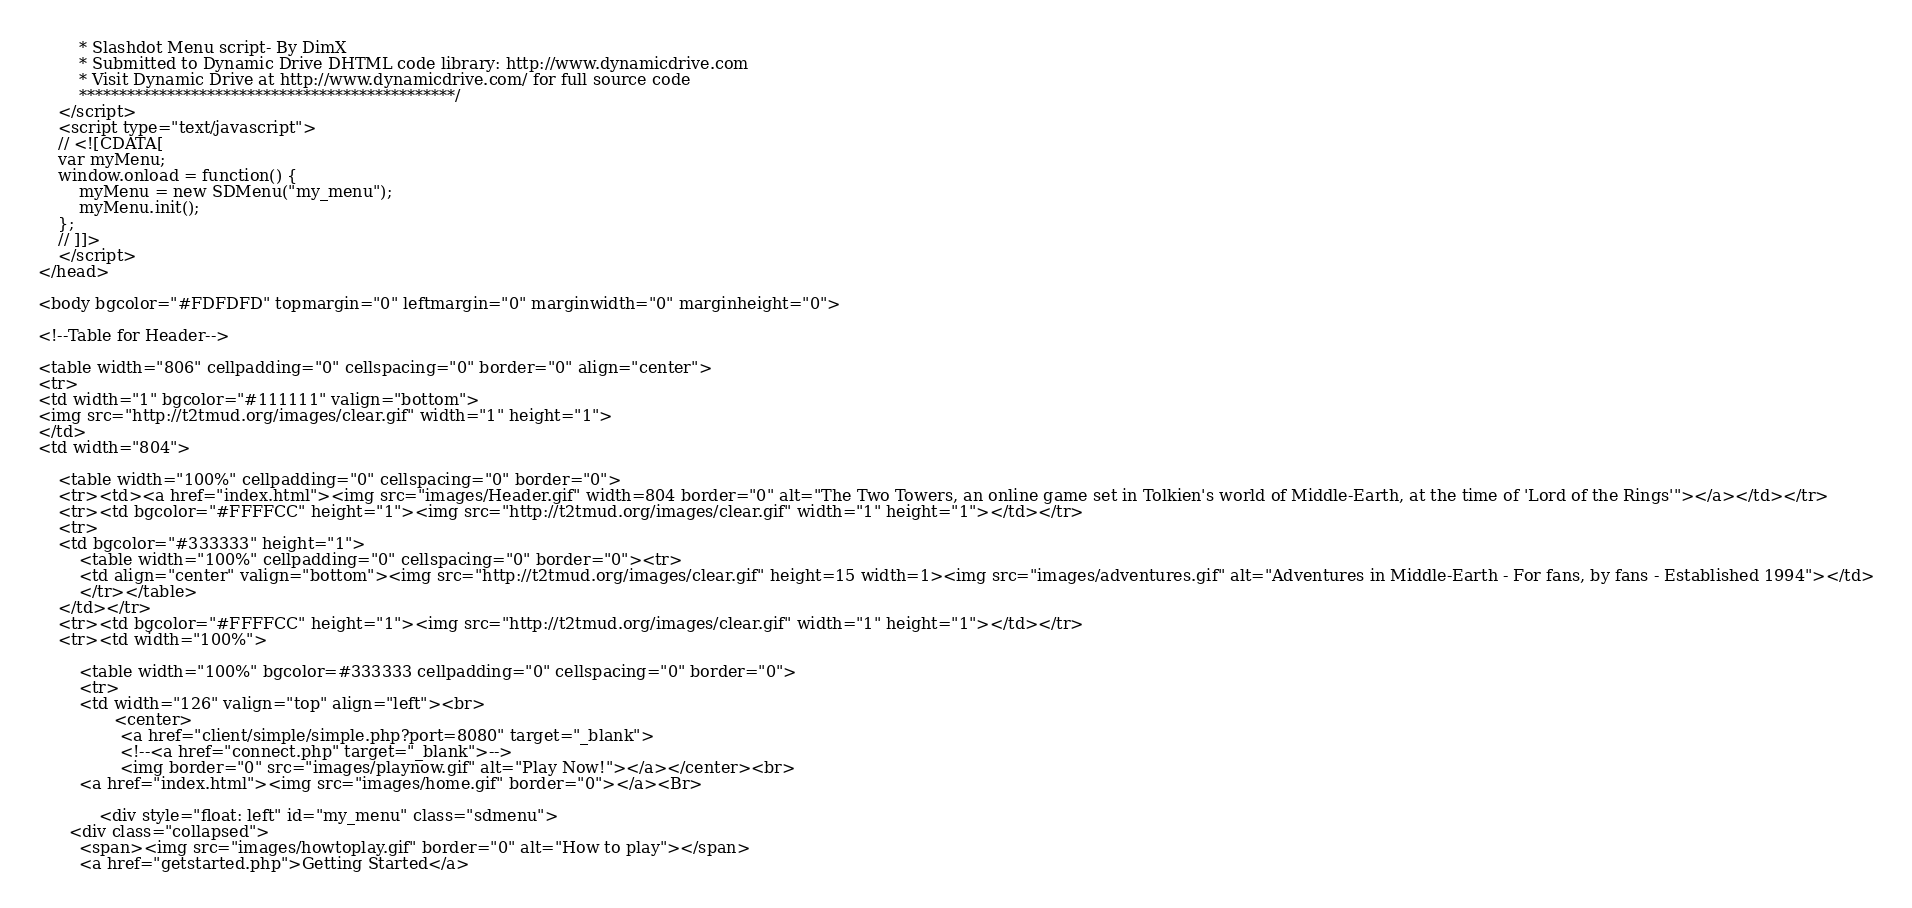Convert code to text. <code><loc_0><loc_0><loc_500><loc_500><_PHP_>		* Slashdot Menu script- By DimX
		* Submitted to Dynamic Drive DHTML code library: http://www.dynamicdrive.com
		* Visit Dynamic Drive at http://www.dynamicdrive.com/ for full source code
		***********************************************/
	</script>
	<script type="text/javascript">
	// <![CDATA[
	var myMenu;
	window.onload = function() {
		myMenu = new SDMenu("my_menu");
		myMenu.init();
	};
	// ]]>
	</script>
</head>

<body bgcolor="#FDFDFD" topmargin="0" leftmargin="0" marginwidth="0" marginheight="0">

<!--Table for Header-->

<table width="806" cellpadding="0" cellspacing="0" border="0" align="center">
<tr>
<td width="1" bgcolor="#111111" valign="bottom">
<img src="http://t2tmud.org/images/clear.gif" width="1" height="1">
</td>
<td width="804">

	<table width="100%" cellpadding="0" cellspacing="0" border="0">
	<tr><td><a href="index.html"><img src="images/Header.gif" width=804 border="0" alt="The Two Towers, an online game set in Tolkien's world of Middle-Earth, at the time of 'Lord of the Rings'"></a></td></tr>
	<tr><td bgcolor="#FFFFCC" height="1"><img src="http://t2tmud.org/images/clear.gif" width="1" height="1"></td></tr>
	<tr>
	<td bgcolor="#333333" height="1">
		<table width="100%" cellpadding="0" cellspacing="0" border="0"><tr>
		<td align="center" valign="bottom"><img src="http://t2tmud.org/images/clear.gif" height=15 width=1><img src="images/adventures.gif" alt="Adventures in Middle-Earth - For fans, by fans - Established 1994"></td>
		</tr></table>
	</td></tr>
	<tr><td bgcolor="#FFFFCC" height="1"><img src="http://t2tmud.org/images/clear.gif" width="1" height="1"></td></tr>
	<tr><td width="100%">
			
		<table width="100%" bgcolor=#333333 cellpadding="0" cellspacing="0" border="0">
		<tr>
		<td width="126" valign="top" align="left"><br>
               <center>
				<a href="client/simple/simple.php?port=8080" target="_blank">
				<!--<a href="connect.php" target="_blank">-->
				<img border="0" src="images/playnow.gif" alt="Play Now!"></a></center><br>
		<a href="index.html"><img src="images/home.gif" border="0"></a><Br>
		
		    <div style="float: left" id="my_menu" class="sdmenu">
      <div class="collapsed">
        <span><img src="images/howtoplay.gif" border="0" alt="How to play"></span>
		<a href="getstarted.php">Getting Started</a></code> 